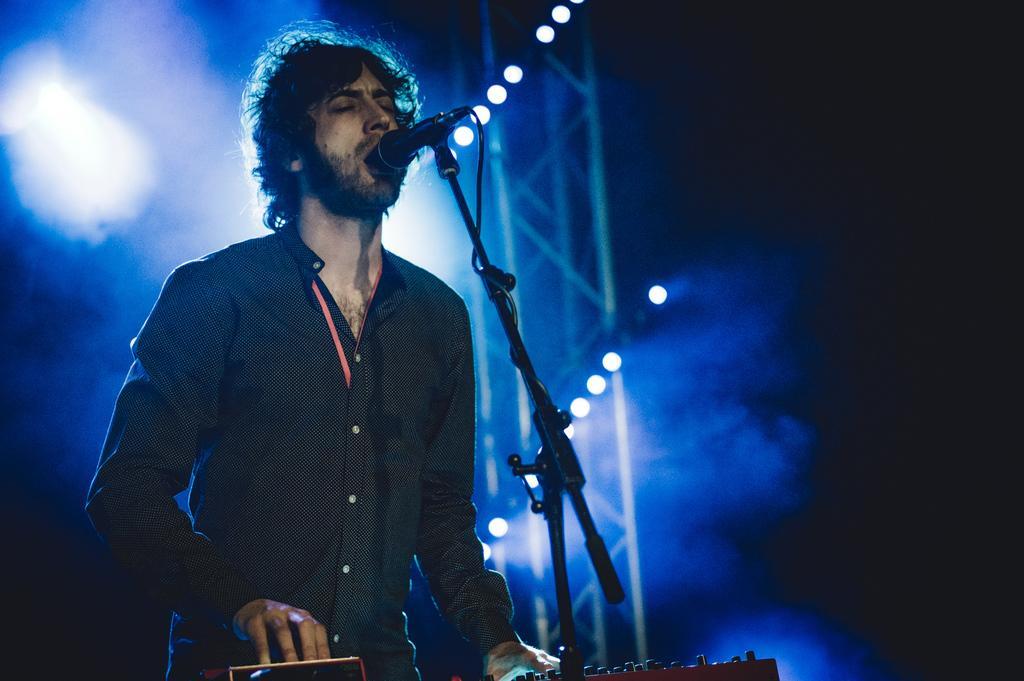Could you give a brief overview of what you see in this image? In this picture there is a person singing and in front of him there is a mike. At the background there are lights. 